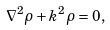<formula> <loc_0><loc_0><loc_500><loc_500>\nabla ^ { 2 } \rho + k ^ { 2 } \rho = 0 ,</formula> 